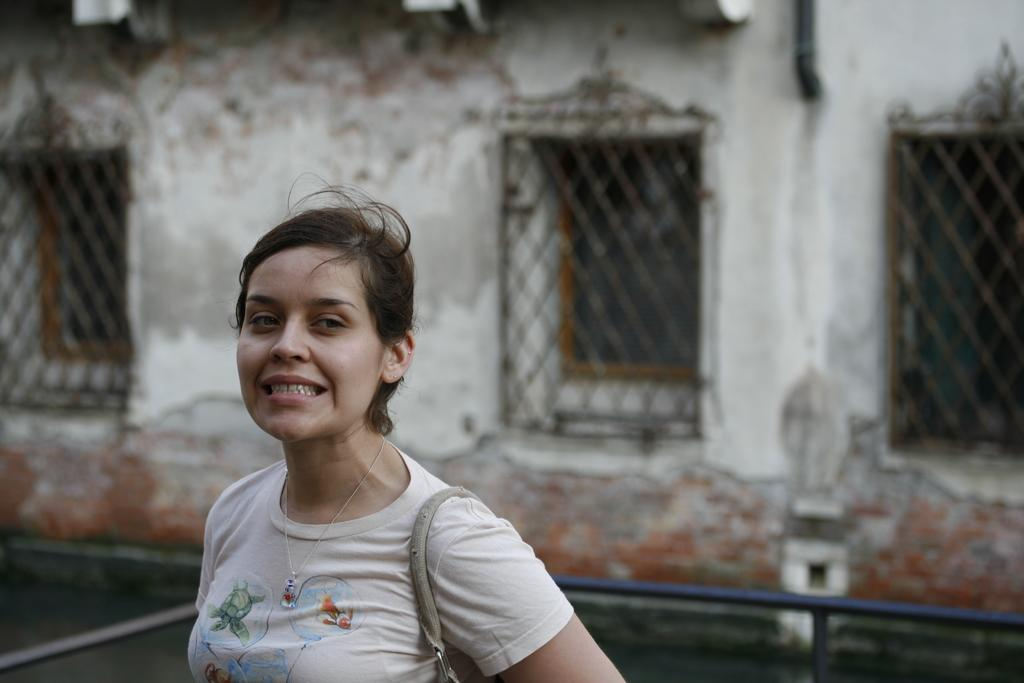Who is present in the image? There is a woman in the image. What type of objects can be seen in the image? Metal rods are visible in the image. What type of structure is present in the image? There is a building in the image. What type of hat is the woman wearing in the image? There is no hat visible in the image. Where is the market located in the image? There is no market present in the image. 